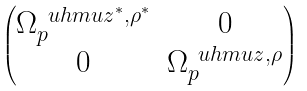<formula> <loc_0><loc_0><loc_500><loc_500>\begin{pmatrix} \Omega _ { p } ^ { \ u h m u z ^ { * } , \rho ^ { * } } & 0 \\ 0 & \Omega _ { p } ^ { \ u h m u z , \rho } \end{pmatrix}</formula> 